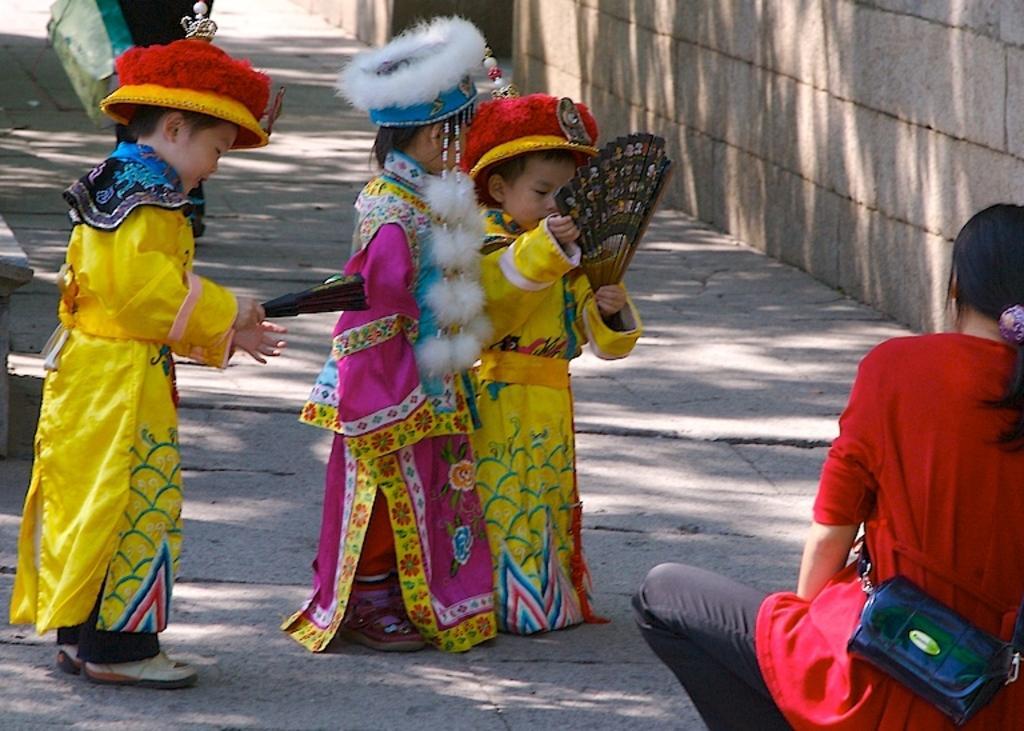Can you describe this image briefly? This image is taken outdoors. At the bottom of the image there is a floor. In the middle of the image three kids are standing on the floor and they are holding hand-fans in their hands. They are dressed differently. On the right side of the image a woman is sitting on the ground and there is a wall. 